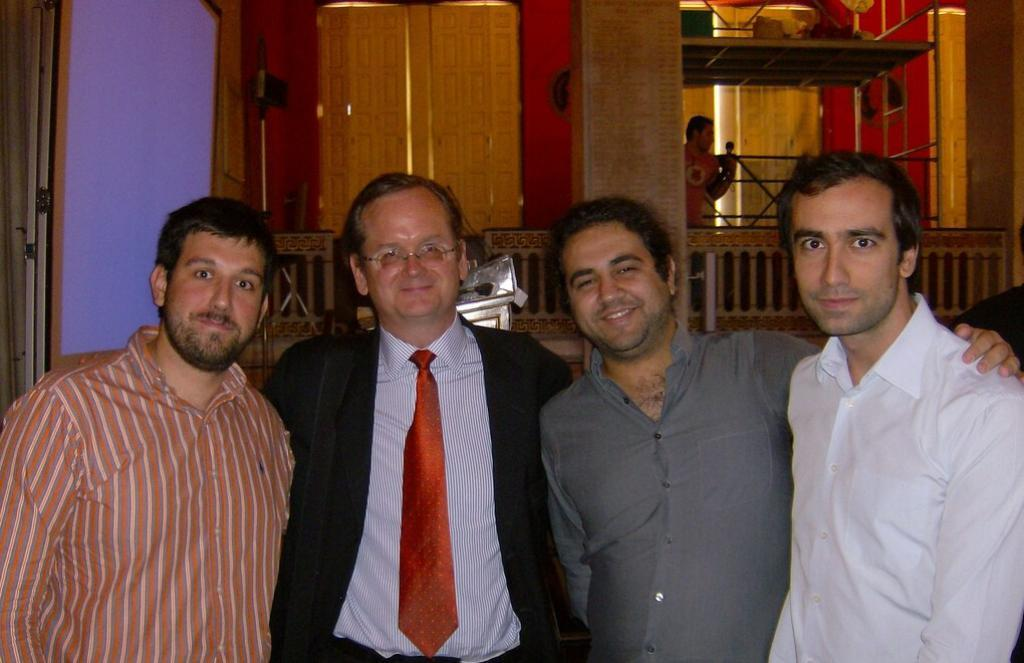What are the people in the image doing? The people in the image are standing and smiling. What can be seen in the background of the image? There is a wall and fencing in the background of the image. Can you describe the man's position in the image? The man is standing behind the fencing. What is the man holding in his hand? The man is holding something in his hand, but we cannot determine what it is from the image. What type of attack is being carried out by the pigs in the image? There are no pigs present in the image, so no such attack can be observed. 